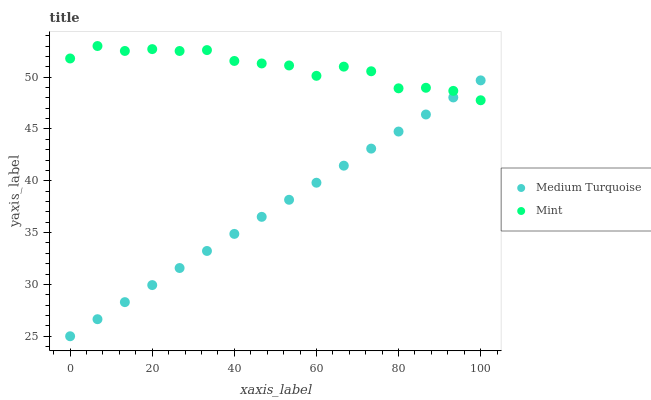Does Medium Turquoise have the minimum area under the curve?
Answer yes or no. Yes. Does Mint have the maximum area under the curve?
Answer yes or no. Yes. Does Medium Turquoise have the maximum area under the curve?
Answer yes or no. No. Is Medium Turquoise the smoothest?
Answer yes or no. Yes. Is Mint the roughest?
Answer yes or no. Yes. Is Medium Turquoise the roughest?
Answer yes or no. No. Does Medium Turquoise have the lowest value?
Answer yes or no. Yes. Does Mint have the highest value?
Answer yes or no. Yes. Does Medium Turquoise have the highest value?
Answer yes or no. No. Does Medium Turquoise intersect Mint?
Answer yes or no. Yes. Is Medium Turquoise less than Mint?
Answer yes or no. No. Is Medium Turquoise greater than Mint?
Answer yes or no. No. 